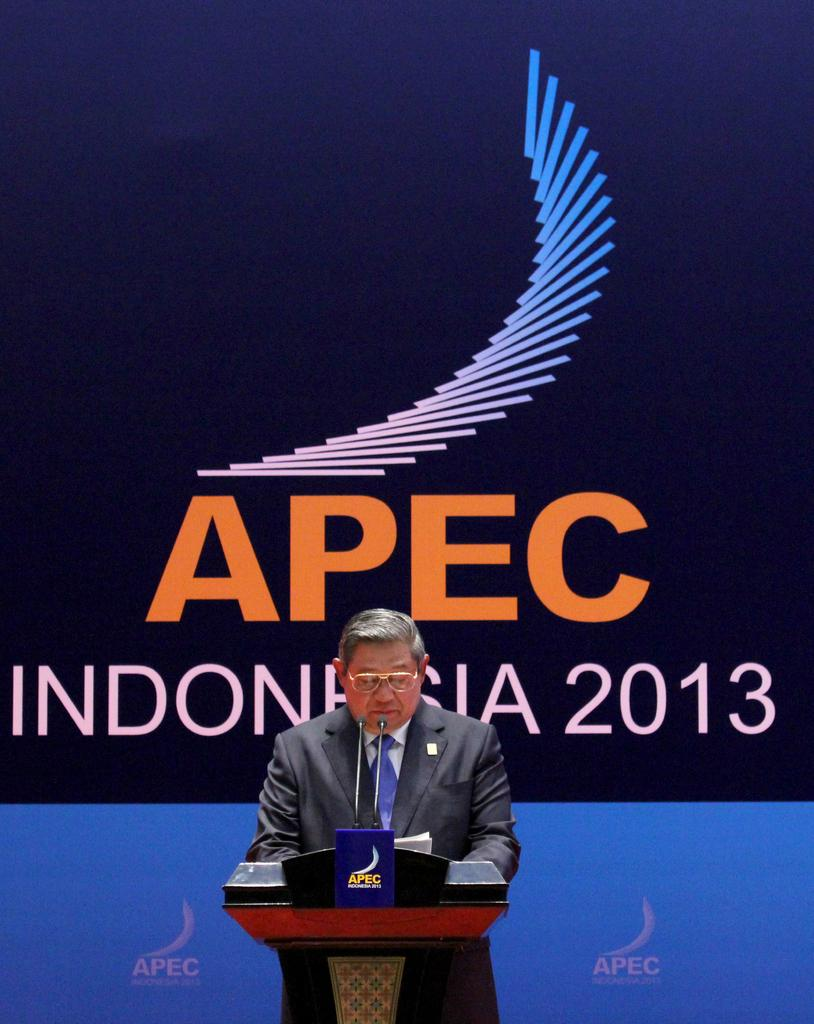<image>
Describe the image concisely. an APEC sign behind a man at a microphone 